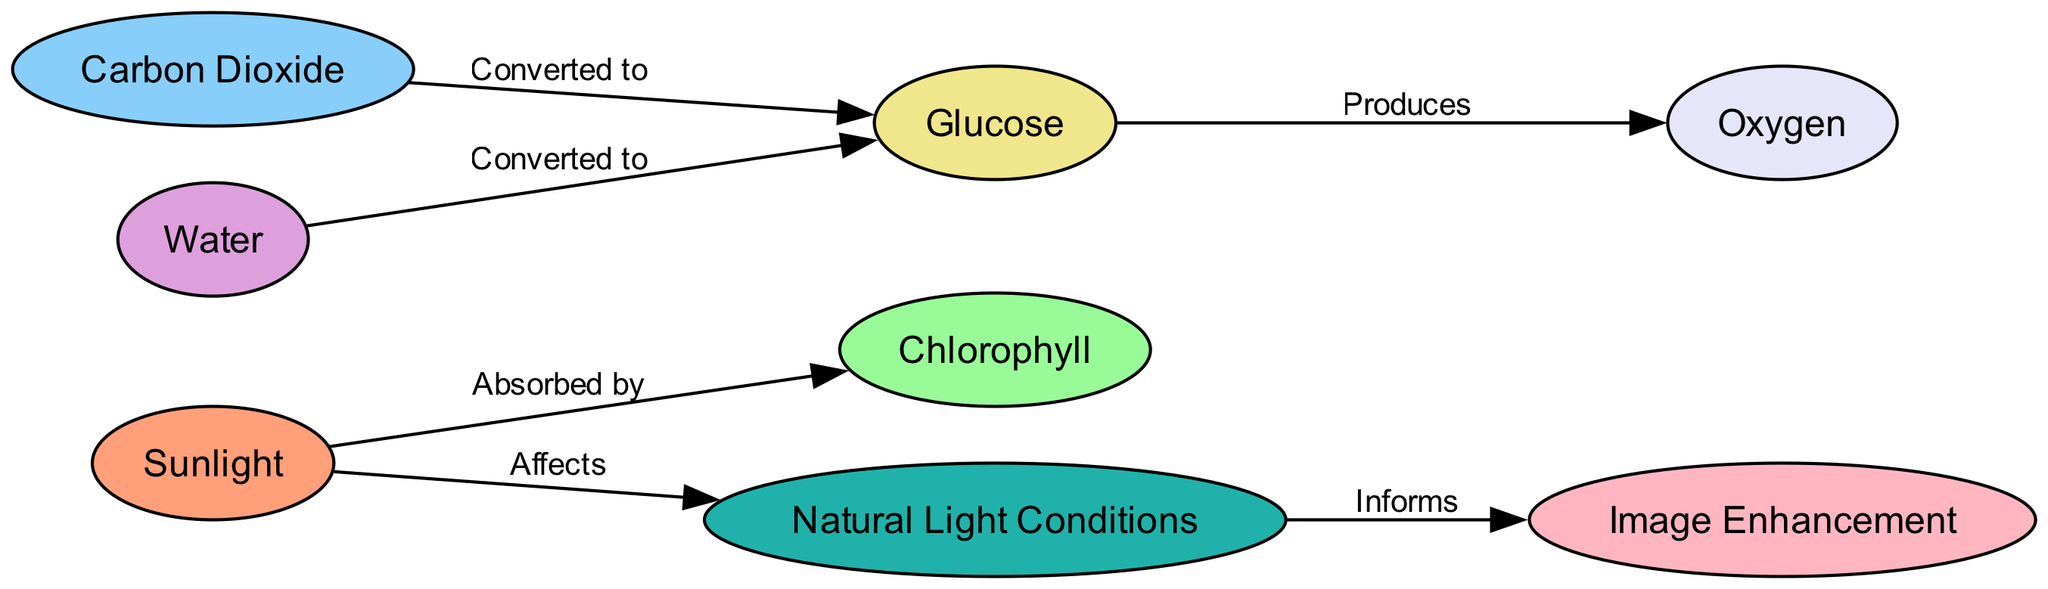What is the first node in the diagram? The first node in the diagram is labeled "Sunlight," which is the starting point of the process of photosynthesis.
Answer: Sunlight How many nodes are present in the diagram? A count of the nodes listed in the diagram reveals there are eight distinct nodes.
Answer: 8 What is the relationship between Water and Glucose? The diagram indicates that Water is "Converted to" Glucose, depicting an important step in the photosynthesis process.
Answer: Converted to Which two nodes produce Oxygen? The nodes Glucose and Water lead to the production of Oxygen as indicated in the diagram.
Answer: Glucose and Water What affects Natural Light Conditions? Sunlight is shown to affect Natural Light Conditions in the diagram, illustrating its crucial role in both photosynthesis and photography.
Answer: Sunlight Which node informs Image Enhancement? The arrow from "Natural Light Conditions" to "Image Enhancement" shows that Natural Light Conditions inform Image Enhancement, linking them directly.
Answer: Natural Light Conditions What is converted to Glucose from Carbon Dioxide? The diagram specifies that Carbon Dioxide is "Converted to" Glucose as part of the photosynthesis process.
Answer: Glucose What processes lead to the production of Oxygen? The flow from Glucose and Water both leads to the production of Oxygen, illustrating a key output of photosynthesis.
Answer: Glucose and Water What influences the relationship between Natural Light Conditions and Image Enhancement? The diagram indicates that Natural Light Conditions, influenced by Sunlight, directly inform Image Enhancement, establishing a cycle that affects photography.
Answer: Sunlight 